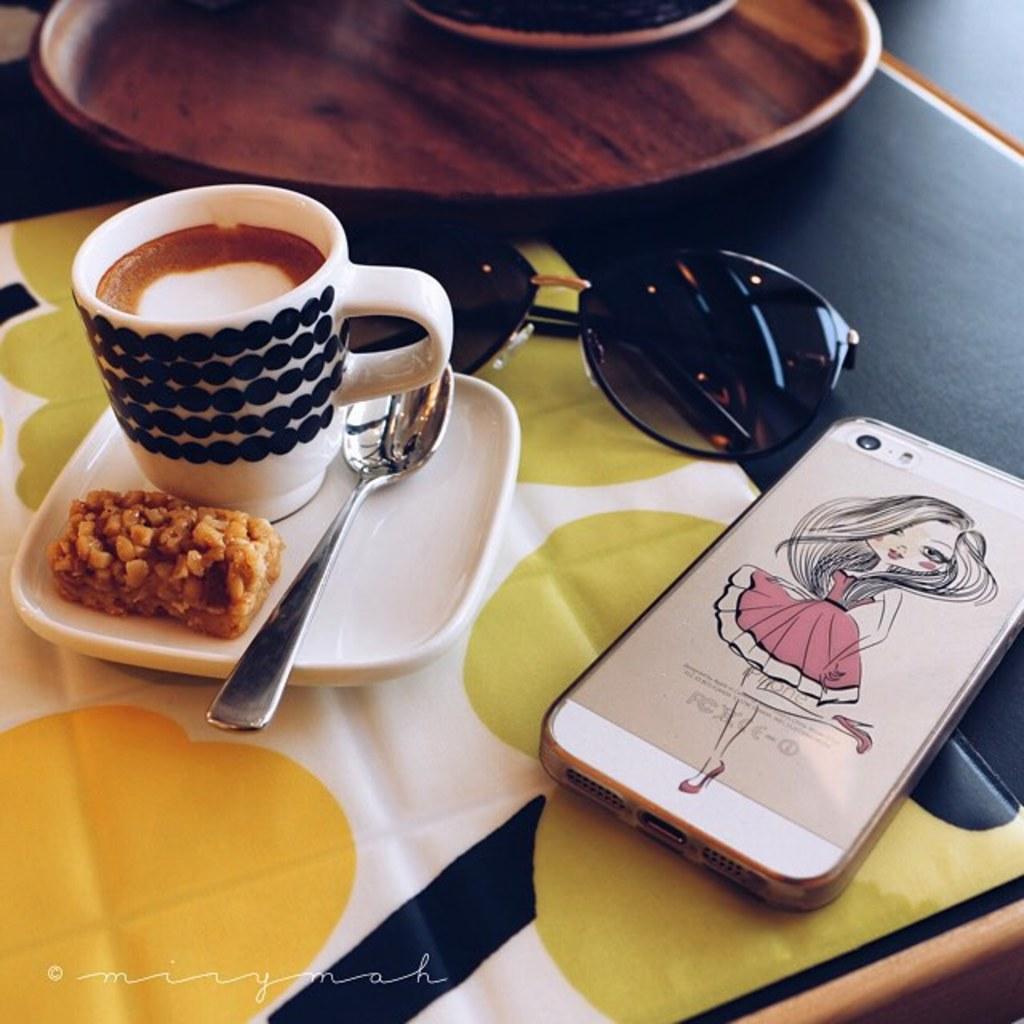Can you describe this image briefly? The picture consists of one mobile,sunglasses,cup,saucer and a spoon and a bar and napkin and plate. 